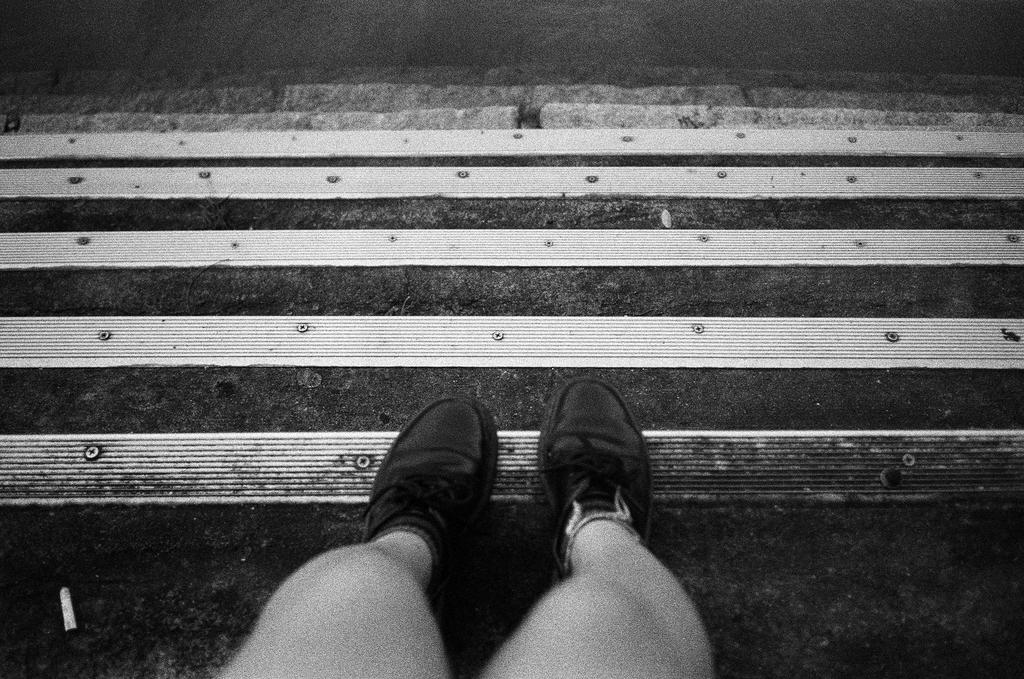What is the color scheme of the image? The image is black and white. What part of a person can be seen in the image? There are person's legs with footwear in the image. What architectural feature is present in the image? There are steps in the image. What type of hill can be seen in the background of the image? There is no hill visible in the image; it is black and white and only features a person's legs with footwear and steps. Is there a ship docked near the steps in the image? There is no ship present in the image; it only features a person's legs with footwear and steps. 